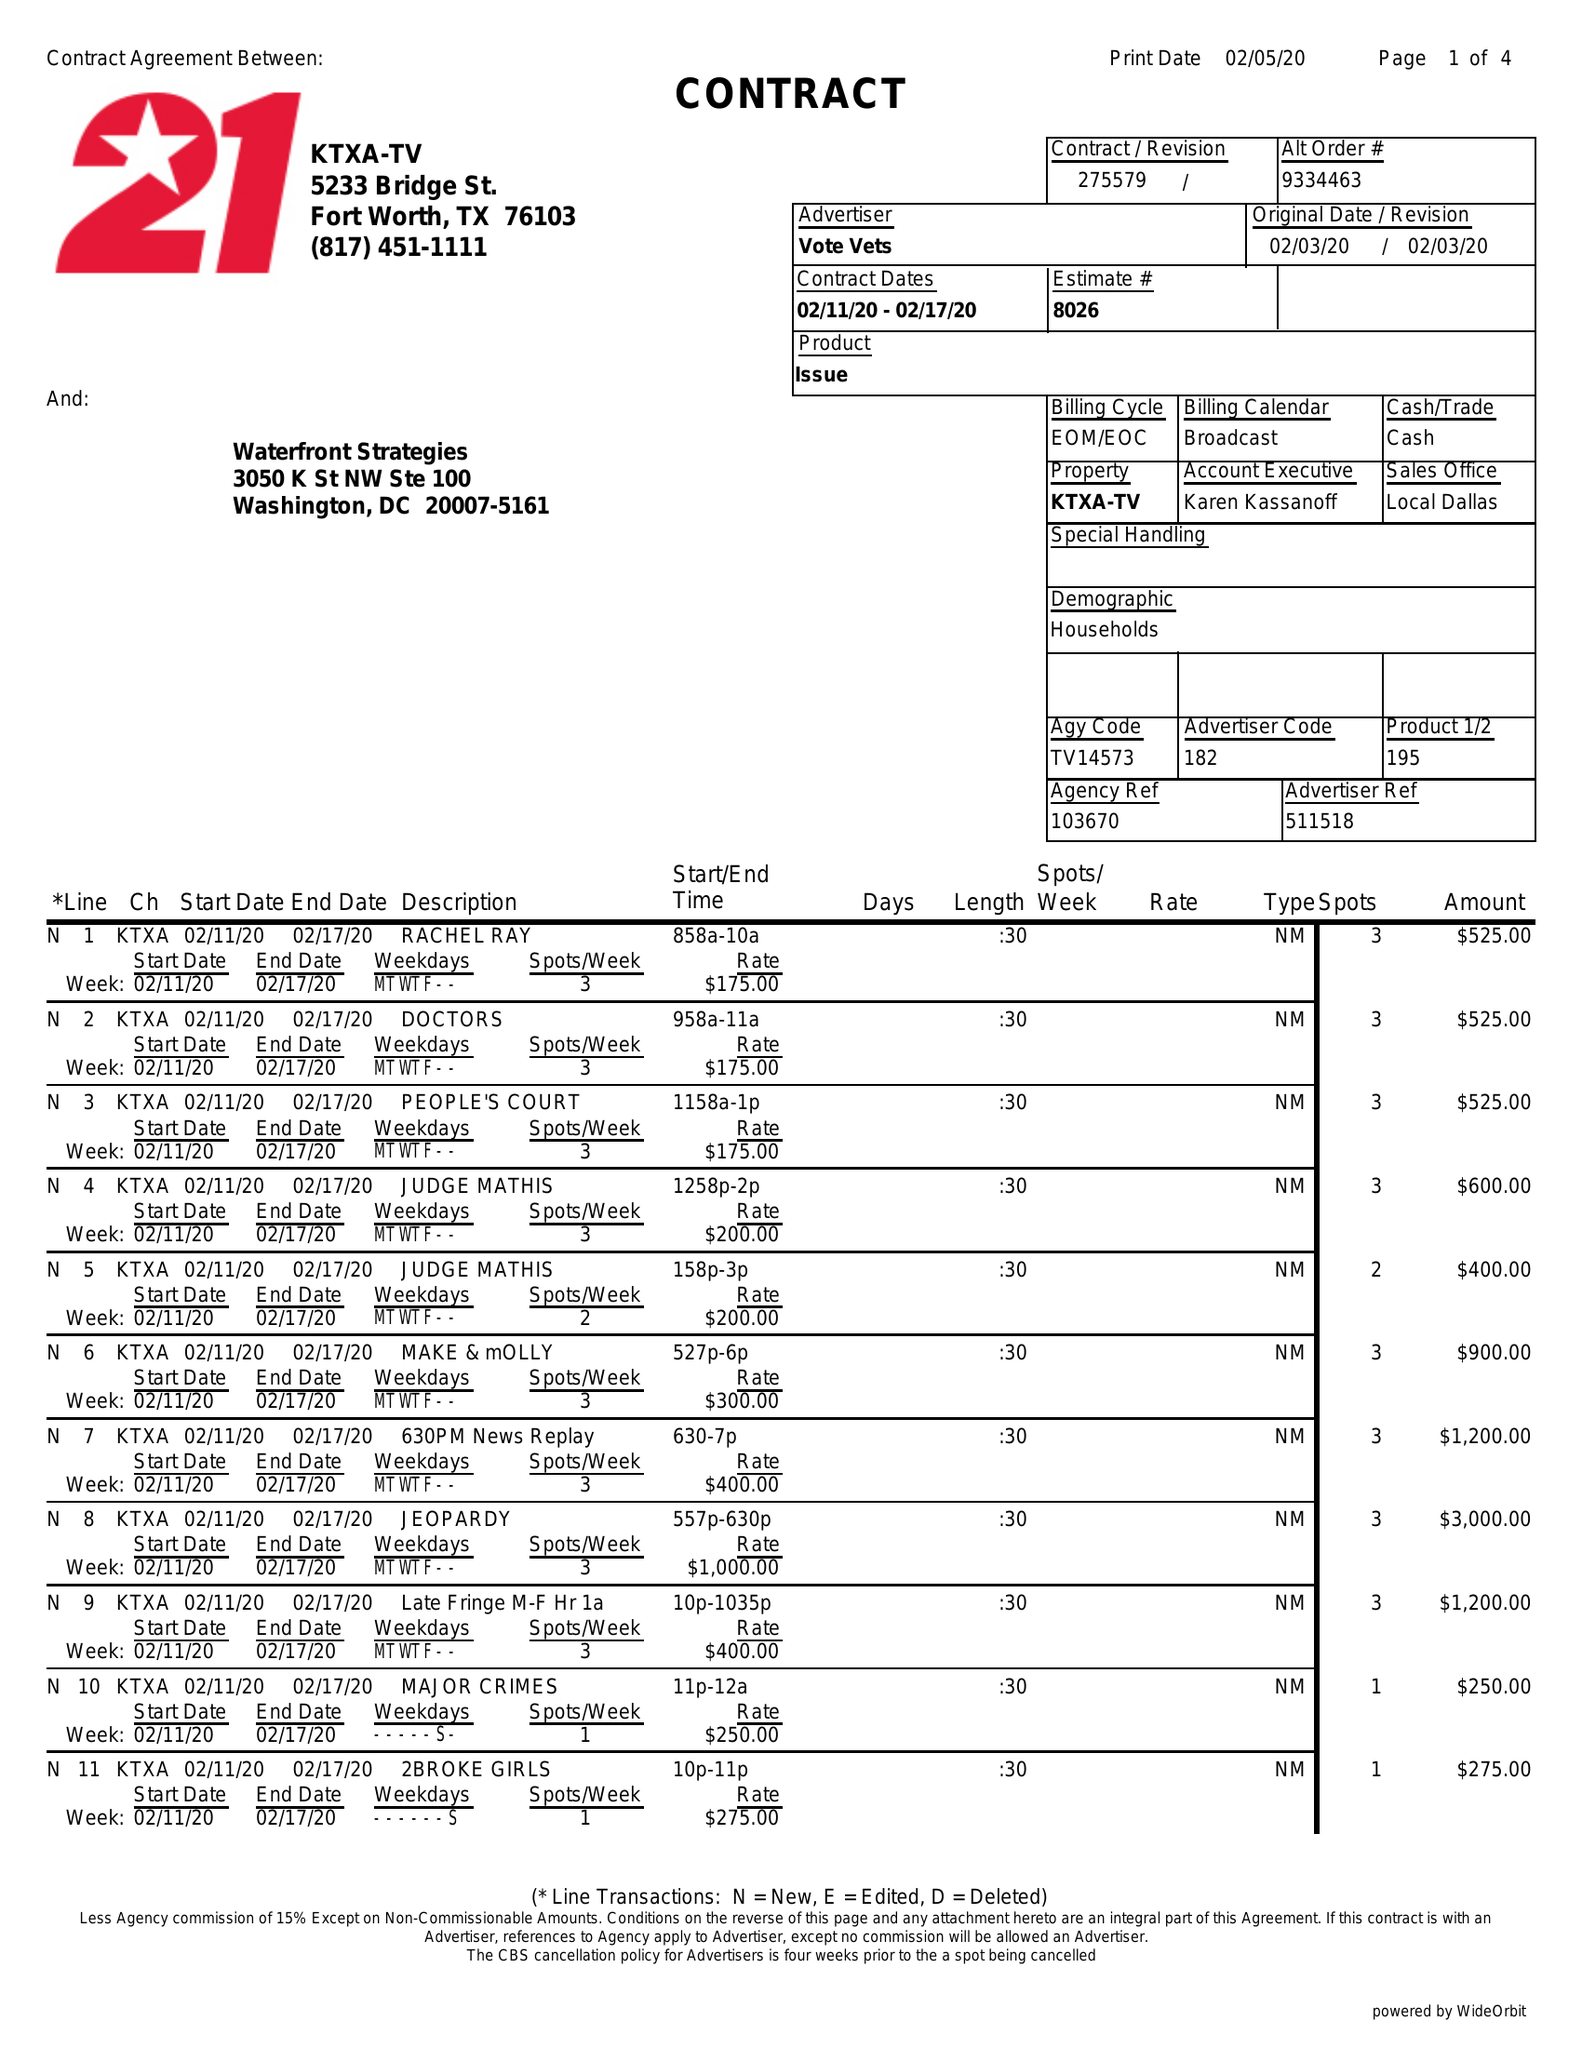What is the value for the advertiser?
Answer the question using a single word or phrase. VOTE VETS 